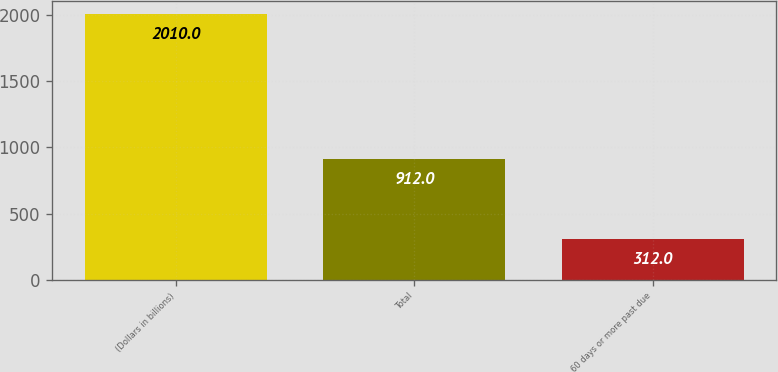<chart> <loc_0><loc_0><loc_500><loc_500><bar_chart><fcel>(Dollars in billions)<fcel>Total<fcel>60 days or more past due<nl><fcel>2010<fcel>912<fcel>312<nl></chart> 